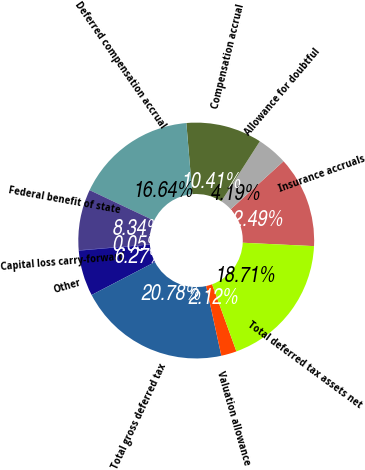Convert chart. <chart><loc_0><loc_0><loc_500><loc_500><pie_chart><fcel>Insurance accruals<fcel>Allowance for doubtful<fcel>Compensation accrual<fcel>Deferred compensation accrual<fcel>Federal benefit of state<fcel>Capital loss carry-forward<fcel>Other<fcel>Total gross deferred tax<fcel>Valuation allowance<fcel>Total deferred tax assets net<nl><fcel>12.49%<fcel>4.19%<fcel>10.41%<fcel>16.64%<fcel>8.34%<fcel>0.05%<fcel>6.27%<fcel>20.78%<fcel>2.12%<fcel>18.71%<nl></chart> 